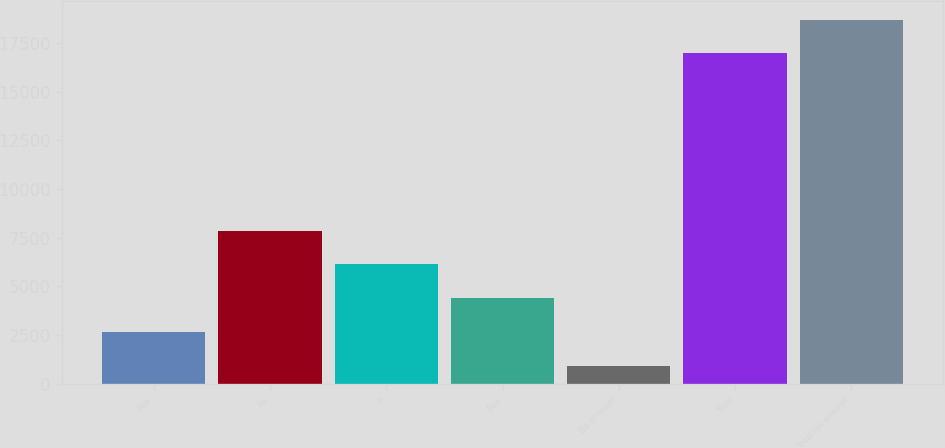Convert chart. <chart><loc_0><loc_0><loc_500><loc_500><bar_chart><fcel>Aaa<fcel>Aa<fcel>A<fcel>Baa<fcel>Ba or lower<fcel>Total<fcel>Total tax exempt<nl><fcel>2663.5<fcel>7864<fcel>6130.5<fcel>4397<fcel>930<fcel>16977<fcel>18710.5<nl></chart> 